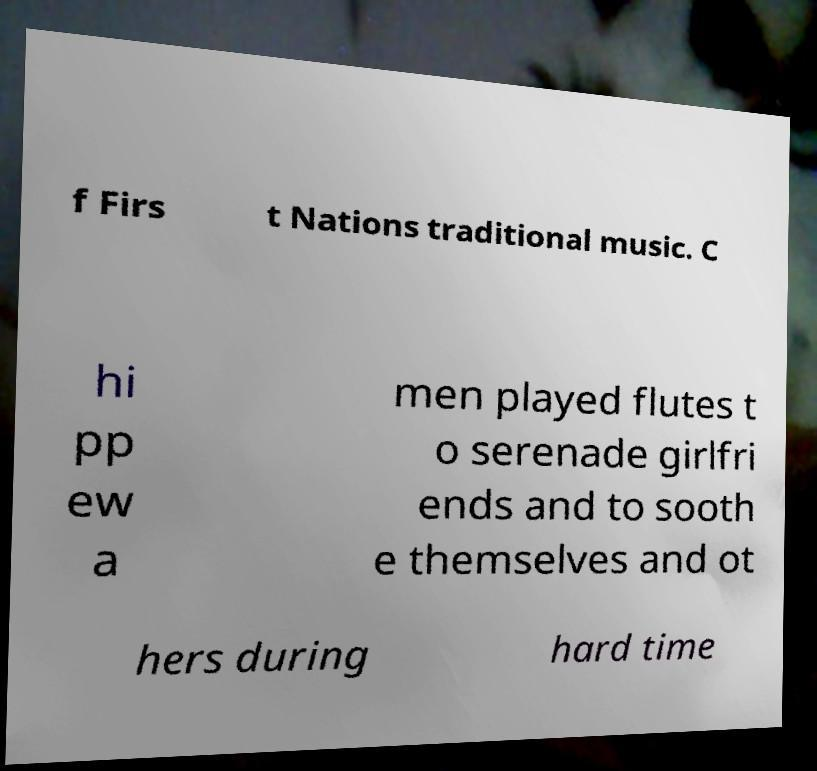For documentation purposes, I need the text within this image transcribed. Could you provide that? f Firs t Nations traditional music. C hi pp ew a men played flutes t o serenade girlfri ends and to sooth e themselves and ot hers during hard time 